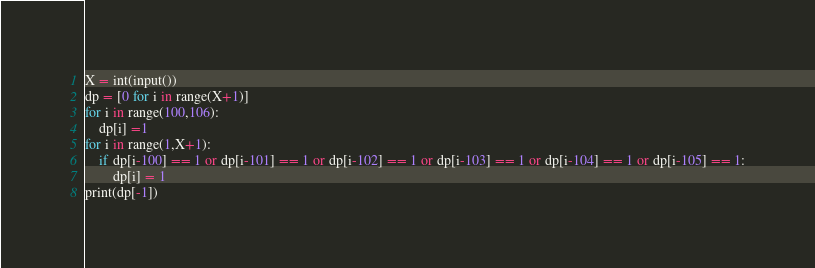Convert code to text. <code><loc_0><loc_0><loc_500><loc_500><_Python_>X = int(input())
dp = [0 for i in range(X+1)]
for i in range(100,106):
    dp[i] =1
for i in range(1,X+1):
    if dp[i-100] == 1 or dp[i-101] == 1 or dp[i-102] == 1 or dp[i-103] == 1 or dp[i-104] == 1 or dp[i-105] == 1:
        dp[i] = 1
print(dp[-1])</code> 